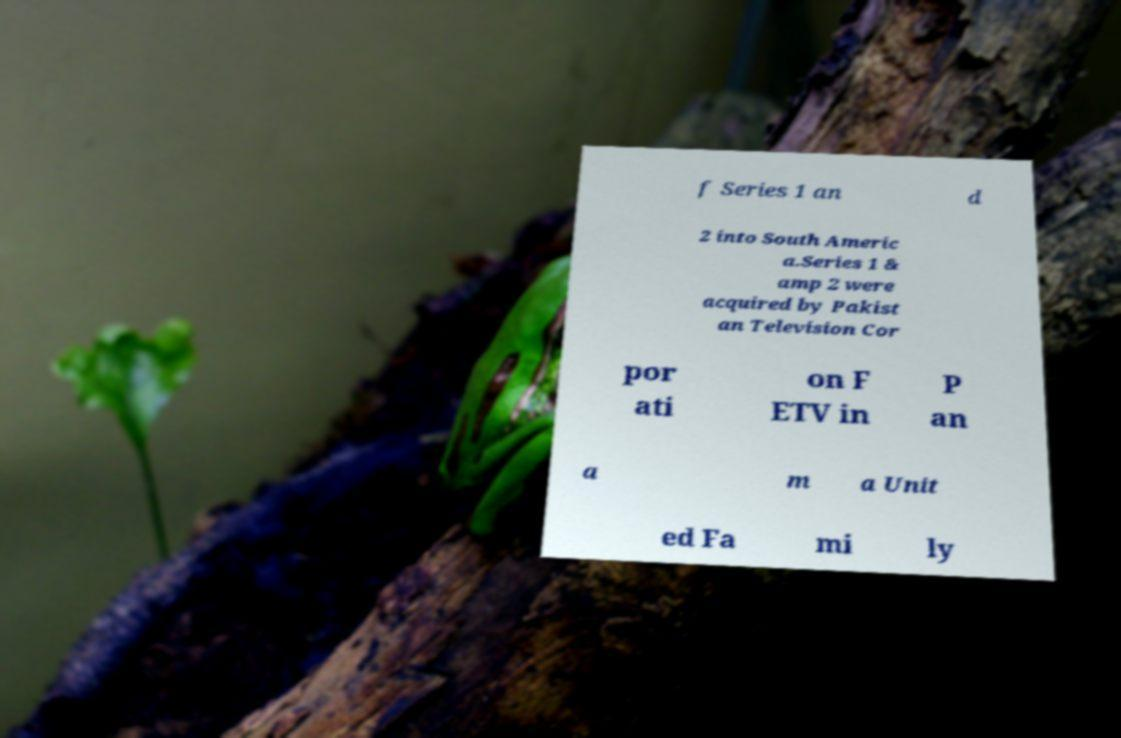For documentation purposes, I need the text within this image transcribed. Could you provide that? f Series 1 an d 2 into South Americ a.Series 1 & amp 2 were acquired by Pakist an Television Cor por ati on F ETV in P an a m a Unit ed Fa mi ly 